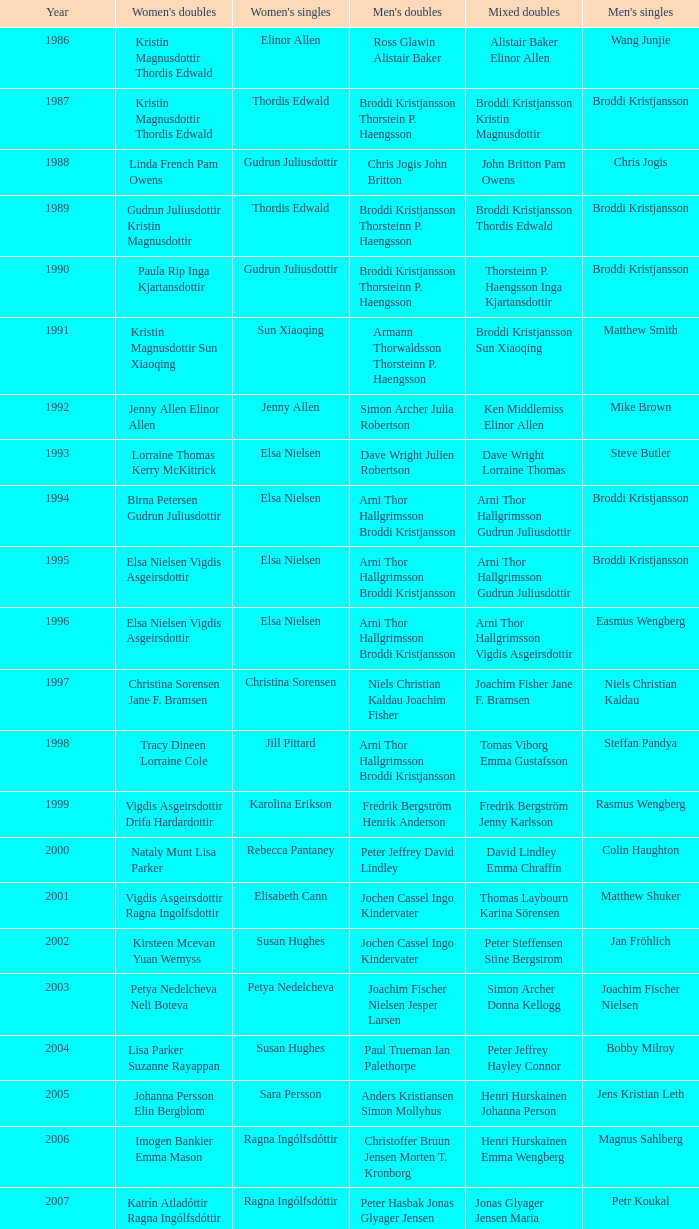Parse the full table. {'header': ['Year', "Women's doubles", "Women's singles", "Men's doubles", 'Mixed doubles', "Men's singles"], 'rows': [['1986', 'Kristin Magnusdottir Thordis Edwald', 'Elinor Allen', 'Ross Glawin Alistair Baker', 'Alistair Baker Elinor Allen', 'Wang Junjie'], ['1987', 'Kristin Magnusdottir Thordis Edwald', 'Thordis Edwald', 'Broddi Kristjansson Thorstein P. Haengsson', 'Broddi Kristjansson Kristin Magnusdottir', 'Broddi Kristjansson'], ['1988', 'Linda French Pam Owens', 'Gudrun Juliusdottir', 'Chris Jogis John Britton', 'John Britton Pam Owens', 'Chris Jogis'], ['1989', 'Gudrun Juliusdottir Kristin Magnusdottir', 'Thordis Edwald', 'Broddi Kristjansson Thorsteinn P. Haengsson', 'Broddi Kristjansson Thordis Edwald', 'Broddi Kristjansson'], ['1990', 'Paula Rip Inga Kjartansdottir', 'Gudrun Juliusdottir', 'Broddi Kristjansson Thorsteinn P. Haengsson', 'Thorsteinn P. Haengsson Inga Kjartansdottir', 'Broddi Kristjansson'], ['1991', 'Kristin Magnusdottir Sun Xiaoqing', 'Sun Xiaoqing', 'Armann Thorwaldsson Thorsteinn P. Haengsson', 'Broddi Kristjansson Sun Xiaoqing', 'Matthew Smith'], ['1992', 'Jenny Allen Elinor Allen', 'Jenny Allen', 'Simon Archer Julia Robertson', 'Ken Middlemiss Elinor Allen', 'Mike Brown'], ['1993', 'Lorraine Thomas Kerry McKittrick', 'Elsa Nielsen', 'Dave Wright Julien Robertson', 'Dave Wright Lorraine Thomas', 'Steve Butler'], ['1994', 'Birna Petersen Gudrun Juliusdottir', 'Elsa Nielsen', 'Arni Thor Hallgrimsson Broddi Kristjansson', 'Arni Thor Hallgrimsson Gudrun Juliusdottir', 'Broddi Kristjansson'], ['1995', 'Elsa Nielsen Vigdis Asgeirsdottir', 'Elsa Nielsen', 'Arni Thor Hallgrimsson Broddi Kristjansson', 'Arni Thor Hallgrimsson Gudrun Juliusdottir', 'Broddi Kristjansson'], ['1996', 'Elsa Nielsen Vigdis Asgeirsdottir', 'Elsa Nielsen', 'Arni Thor Hallgrimsson Broddi Kristjansson', 'Arni Thor Hallgrimsson Vigdis Asgeirsdottir', 'Easmus Wengberg'], ['1997', 'Christina Sorensen Jane F. Bramsen', 'Christina Sorensen', 'Niels Christian Kaldau Joachim Fisher', 'Joachim Fisher Jane F. Bramsen', 'Niels Christian Kaldau'], ['1998', 'Tracy Dineen Lorraine Cole', 'Jill Pittard', 'Arni Thor Hallgrimsson Broddi Kristjansson', 'Tomas Viborg Emma Gustafsson', 'Steffan Pandya'], ['1999', 'Vigdis Asgeirsdottir Drifa Hardardottir', 'Karolina Erikson', 'Fredrik Bergström Henrik Anderson', 'Fredrik Bergström Jenny Karlsson', 'Rasmus Wengberg'], ['2000', 'Nataly Munt Lisa Parker', 'Rebecca Pantaney', 'Peter Jeffrey David Lindley', 'David Lindley Emma Chraffin', 'Colin Haughton'], ['2001', 'Vigdis Asgeirsdottir Ragna Ingolfsdottir', 'Elisabeth Cann', 'Jochen Cassel Ingo Kindervater', 'Thomas Laybourn Karina Sörensen', 'Matthew Shuker'], ['2002', 'Kirsteen Mcevan Yuan Wemyss', 'Susan Hughes', 'Jochen Cassel Ingo Kindervater', 'Peter Steffensen Stine Bergstrom', 'Jan Fröhlich'], ['2003', 'Petya Nedelcheva Neli Boteva', 'Petya Nedelcheva', 'Joachim Fischer Nielsen Jesper Larsen', 'Simon Archer Donna Kellogg', 'Joachim Fischer Nielsen'], ['2004', 'Lisa Parker Suzanne Rayappan', 'Susan Hughes', 'Paul Trueman Ian Palethorpe', 'Peter Jeffrey Hayley Connor', 'Bobby Milroy'], ['2005', 'Johanna Persson Elin Bergblom', 'Sara Persson', 'Anders Kristiansen Simon Mollyhus', 'Henri Hurskainen Johanna Person', 'Jens Kristian Leth'], ['2006', 'Imogen Bankier Emma Mason', 'Ragna Ingólfsdóttir', 'Christoffer Bruun Jensen Morten T. Kronborg', 'Henri Hurskainen Emma Wengberg', 'Magnus Sahlberg'], ['2007', 'Katrín Atladóttir Ragna Ingólfsdóttir', 'Ragna Ingólfsdóttir', 'Peter Hasbak Jonas Glyager Jensen', 'Jonas Glyager Jensen Maria Kaaberböl Thorberg', 'Petr Koukal'], ['2008', 'No competition', 'No competition', 'No competition', 'No competition', 'No competition'], ['2009', 'Ragna Ingólfsdóttir Snjólaug Jóhannsdóttir', 'Ragna Ingólfsdóttir', 'Anders Skaarup Rasmussen René Lindskow', 'Theis Christiansen Joan Christiansen', 'Christian Lind Thomsen'], ['2010', 'Katrín Atladóttir Ragna Ingólfsdóttir', 'Ragna Ingólfsdóttir', 'Emil Holst Mikkel Mikkelsen', 'Frederik Colberg Mette Poulsen', 'Kim Bruun'], ['2011', 'Tinna Helgadóttir Snjólaug Jóhannsdóttir', 'Ragna Ingólfsdóttir', 'Thomas Dew-Hattens Mathias Kany', 'Thomas Dew-Hattens Louise Hansen', 'Mathias Borg'], ['2012', 'Lee So-hee Shin Seung-chan', 'Chiang Mei-hui', 'Joe Morgan Nic Strange', 'Chou Tien-chen Chiang Mei-hui', 'Chou Tien-chen']]} In what mixed doubles did Niels Christian Kaldau play in men's singles? Joachim Fisher Jane F. Bramsen. 